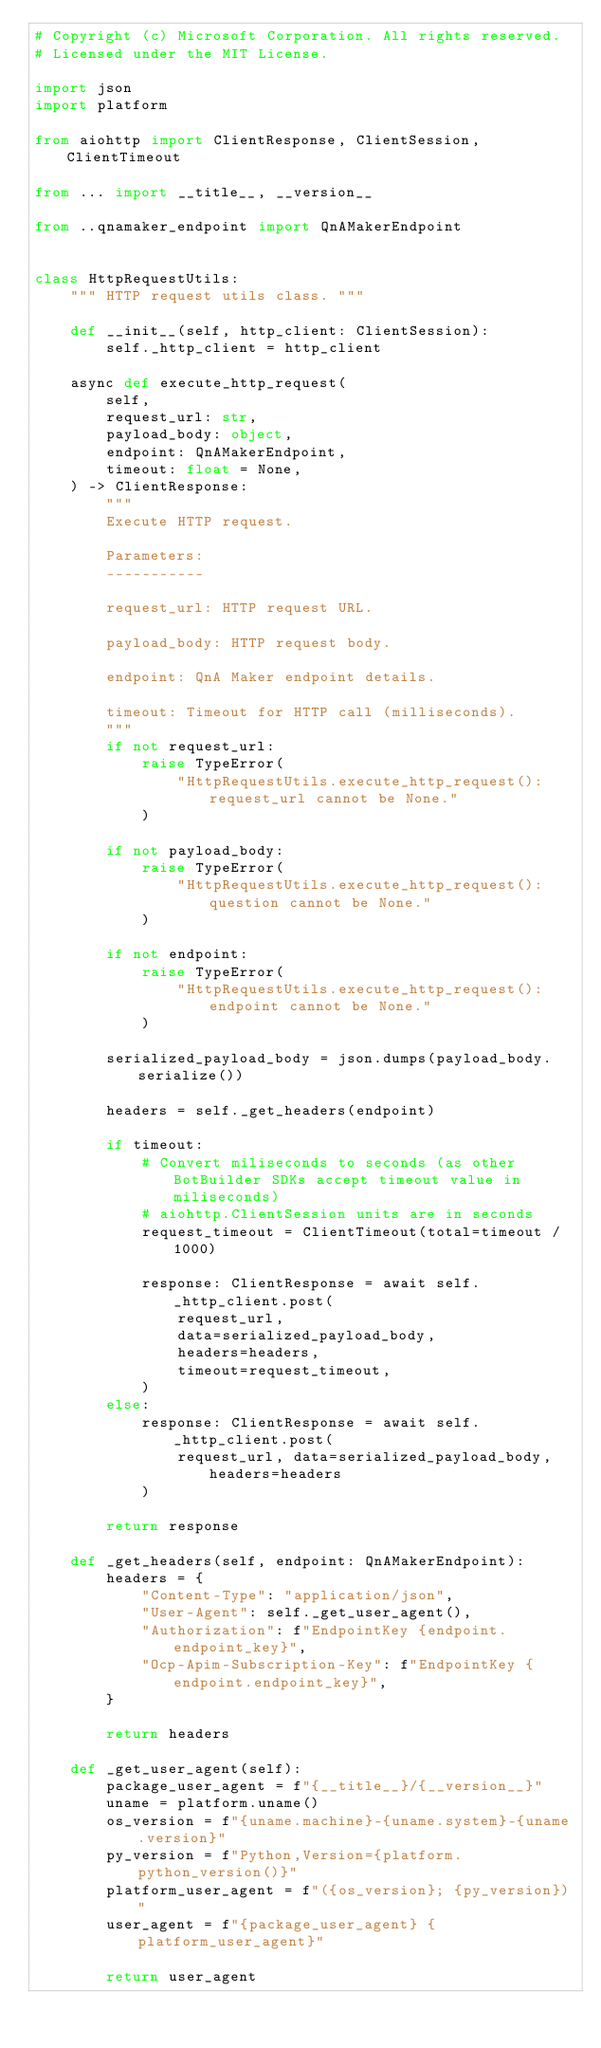<code> <loc_0><loc_0><loc_500><loc_500><_Python_># Copyright (c) Microsoft Corporation. All rights reserved.
# Licensed under the MIT License.

import json
import platform

from aiohttp import ClientResponse, ClientSession, ClientTimeout

from ... import __title__, __version__

from ..qnamaker_endpoint import QnAMakerEndpoint


class HttpRequestUtils:
    """ HTTP request utils class. """

    def __init__(self, http_client: ClientSession):
        self._http_client = http_client

    async def execute_http_request(
        self,
        request_url: str,
        payload_body: object,
        endpoint: QnAMakerEndpoint,
        timeout: float = None,
    ) -> ClientResponse:
        """
        Execute HTTP request.

        Parameters:
        -----------

        request_url: HTTP request URL.

        payload_body: HTTP request body.

        endpoint: QnA Maker endpoint details.

        timeout: Timeout for HTTP call (milliseconds).
        """
        if not request_url:
            raise TypeError(
                "HttpRequestUtils.execute_http_request(): request_url cannot be None."
            )

        if not payload_body:
            raise TypeError(
                "HttpRequestUtils.execute_http_request(): question cannot be None."
            )

        if not endpoint:
            raise TypeError(
                "HttpRequestUtils.execute_http_request(): endpoint cannot be None."
            )

        serialized_payload_body = json.dumps(payload_body.serialize())

        headers = self._get_headers(endpoint)

        if timeout:
            # Convert miliseconds to seconds (as other BotBuilder SDKs accept timeout value in miliseconds)
            # aiohttp.ClientSession units are in seconds
            request_timeout = ClientTimeout(total=timeout / 1000)

            response: ClientResponse = await self._http_client.post(
                request_url,
                data=serialized_payload_body,
                headers=headers,
                timeout=request_timeout,
            )
        else:
            response: ClientResponse = await self._http_client.post(
                request_url, data=serialized_payload_body, headers=headers
            )

        return response

    def _get_headers(self, endpoint: QnAMakerEndpoint):
        headers = {
            "Content-Type": "application/json",
            "User-Agent": self._get_user_agent(),
            "Authorization": f"EndpointKey {endpoint.endpoint_key}",
            "Ocp-Apim-Subscription-Key": f"EndpointKey {endpoint.endpoint_key}",
        }

        return headers

    def _get_user_agent(self):
        package_user_agent = f"{__title__}/{__version__}"
        uname = platform.uname()
        os_version = f"{uname.machine}-{uname.system}-{uname.version}"
        py_version = f"Python,Version={platform.python_version()}"
        platform_user_agent = f"({os_version}; {py_version})"
        user_agent = f"{package_user_agent} {platform_user_agent}"

        return user_agent
</code> 